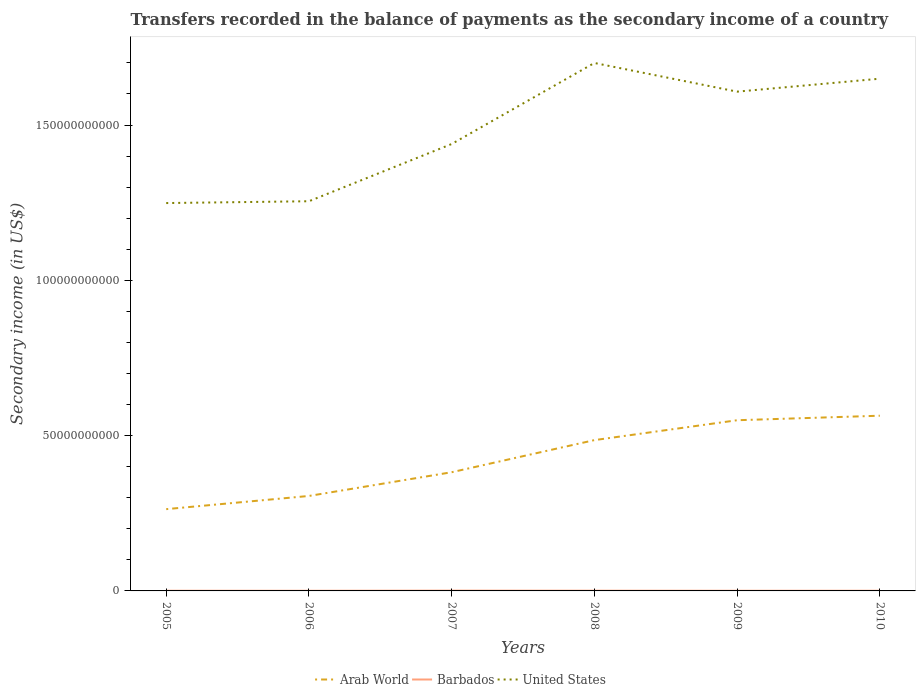How many different coloured lines are there?
Offer a terse response. 3. Does the line corresponding to Arab World intersect with the line corresponding to United States?
Offer a very short reply. No. Across all years, what is the maximum secondary income of in Arab World?
Provide a succinct answer. 2.63e+1. In which year was the secondary income of in United States maximum?
Offer a terse response. 2005. What is the total secondary income of in United States in the graph?
Keep it short and to the point. -1.90e+1. What is the difference between the highest and the second highest secondary income of in United States?
Your answer should be very brief. 4.51e+1. What is the difference between the highest and the lowest secondary income of in Arab World?
Your answer should be very brief. 3. Is the secondary income of in Arab World strictly greater than the secondary income of in Barbados over the years?
Offer a very short reply. No. How many lines are there?
Provide a succinct answer. 3. How many years are there in the graph?
Give a very brief answer. 6. Are the values on the major ticks of Y-axis written in scientific E-notation?
Your answer should be very brief. No. Does the graph contain any zero values?
Your answer should be compact. No. Does the graph contain grids?
Offer a terse response. No. Where does the legend appear in the graph?
Offer a very short reply. Bottom center. How many legend labels are there?
Keep it short and to the point. 3. What is the title of the graph?
Your response must be concise. Transfers recorded in the balance of payments as the secondary income of a country. Does "Ukraine" appear as one of the legend labels in the graph?
Your response must be concise. No. What is the label or title of the Y-axis?
Your answer should be very brief. Secondary income (in US$). What is the Secondary income (in US$) in Arab World in 2005?
Offer a very short reply. 2.63e+1. What is the Secondary income (in US$) in Barbados in 2005?
Make the answer very short. 5.83e+07. What is the Secondary income (in US$) of United States in 2005?
Your response must be concise. 1.25e+11. What is the Secondary income (in US$) in Arab World in 2006?
Provide a short and direct response. 3.06e+1. What is the Secondary income (in US$) in Barbados in 2006?
Provide a succinct answer. 4.97e+07. What is the Secondary income (in US$) in United States in 2006?
Provide a short and direct response. 1.25e+11. What is the Secondary income (in US$) of Arab World in 2007?
Make the answer very short. 3.82e+1. What is the Secondary income (in US$) of Barbados in 2007?
Offer a terse response. 9.69e+07. What is the Secondary income (in US$) in United States in 2007?
Your answer should be very brief. 1.44e+11. What is the Secondary income (in US$) of Arab World in 2008?
Provide a short and direct response. 4.86e+1. What is the Secondary income (in US$) of Barbados in 2008?
Make the answer very short. 7.56e+07. What is the Secondary income (in US$) of United States in 2008?
Your answer should be very brief. 1.70e+11. What is the Secondary income (in US$) in Arab World in 2009?
Your response must be concise. 5.50e+1. What is the Secondary income (in US$) in Barbados in 2009?
Offer a very short reply. 5.61e+07. What is the Secondary income (in US$) in United States in 2009?
Your response must be concise. 1.61e+11. What is the Secondary income (in US$) of Arab World in 2010?
Your answer should be compact. 5.64e+1. What is the Secondary income (in US$) in Barbados in 2010?
Offer a very short reply. 6.13e+07. What is the Secondary income (in US$) in United States in 2010?
Your response must be concise. 1.65e+11. Across all years, what is the maximum Secondary income (in US$) of Arab World?
Keep it short and to the point. 5.64e+1. Across all years, what is the maximum Secondary income (in US$) of Barbados?
Ensure brevity in your answer.  9.69e+07. Across all years, what is the maximum Secondary income (in US$) of United States?
Your answer should be compact. 1.70e+11. Across all years, what is the minimum Secondary income (in US$) in Arab World?
Give a very brief answer. 2.63e+1. Across all years, what is the minimum Secondary income (in US$) in Barbados?
Your answer should be compact. 4.97e+07. Across all years, what is the minimum Secondary income (in US$) of United States?
Ensure brevity in your answer.  1.25e+11. What is the total Secondary income (in US$) of Arab World in the graph?
Give a very brief answer. 2.55e+11. What is the total Secondary income (in US$) of Barbados in the graph?
Ensure brevity in your answer.  3.98e+08. What is the total Secondary income (in US$) of United States in the graph?
Keep it short and to the point. 8.90e+11. What is the difference between the Secondary income (in US$) in Arab World in 2005 and that in 2006?
Your answer should be very brief. -4.25e+09. What is the difference between the Secondary income (in US$) of Barbados in 2005 and that in 2006?
Provide a short and direct response. 8.51e+06. What is the difference between the Secondary income (in US$) of United States in 2005 and that in 2006?
Your response must be concise. -5.83e+08. What is the difference between the Secondary income (in US$) of Arab World in 2005 and that in 2007?
Provide a short and direct response. -1.19e+1. What is the difference between the Secondary income (in US$) of Barbados in 2005 and that in 2007?
Offer a terse response. -3.86e+07. What is the difference between the Secondary income (in US$) in United States in 2005 and that in 2007?
Your response must be concise. -1.90e+1. What is the difference between the Secondary income (in US$) of Arab World in 2005 and that in 2008?
Provide a succinct answer. -2.22e+1. What is the difference between the Secondary income (in US$) in Barbados in 2005 and that in 2008?
Your answer should be compact. -1.73e+07. What is the difference between the Secondary income (in US$) in United States in 2005 and that in 2008?
Ensure brevity in your answer.  -4.51e+1. What is the difference between the Secondary income (in US$) in Arab World in 2005 and that in 2009?
Ensure brevity in your answer.  -2.86e+1. What is the difference between the Secondary income (in US$) of Barbados in 2005 and that in 2009?
Your answer should be very brief. 2.20e+06. What is the difference between the Secondary income (in US$) in United States in 2005 and that in 2009?
Your answer should be very brief. -3.59e+1. What is the difference between the Secondary income (in US$) in Arab World in 2005 and that in 2010?
Give a very brief answer. -3.01e+1. What is the difference between the Secondary income (in US$) of Barbados in 2005 and that in 2010?
Provide a succinct answer. -3.06e+06. What is the difference between the Secondary income (in US$) in United States in 2005 and that in 2010?
Offer a terse response. -4.00e+1. What is the difference between the Secondary income (in US$) in Arab World in 2006 and that in 2007?
Offer a very short reply. -7.64e+09. What is the difference between the Secondary income (in US$) of Barbados in 2006 and that in 2007?
Keep it short and to the point. -4.71e+07. What is the difference between the Secondary income (in US$) of United States in 2006 and that in 2007?
Give a very brief answer. -1.84e+1. What is the difference between the Secondary income (in US$) in Arab World in 2006 and that in 2008?
Your response must be concise. -1.80e+1. What is the difference between the Secondary income (in US$) in Barbados in 2006 and that in 2008?
Ensure brevity in your answer.  -2.58e+07. What is the difference between the Secondary income (in US$) in United States in 2006 and that in 2008?
Ensure brevity in your answer.  -4.45e+1. What is the difference between the Secondary income (in US$) of Arab World in 2006 and that in 2009?
Make the answer very short. -2.44e+1. What is the difference between the Secondary income (in US$) in Barbados in 2006 and that in 2009?
Give a very brief answer. -6.32e+06. What is the difference between the Secondary income (in US$) in United States in 2006 and that in 2009?
Give a very brief answer. -3.53e+1. What is the difference between the Secondary income (in US$) of Arab World in 2006 and that in 2010?
Offer a very short reply. -2.58e+1. What is the difference between the Secondary income (in US$) of Barbados in 2006 and that in 2010?
Your answer should be very brief. -1.16e+07. What is the difference between the Secondary income (in US$) of United States in 2006 and that in 2010?
Ensure brevity in your answer.  -3.95e+1. What is the difference between the Secondary income (in US$) in Arab World in 2007 and that in 2008?
Your answer should be compact. -1.03e+1. What is the difference between the Secondary income (in US$) of Barbados in 2007 and that in 2008?
Provide a short and direct response. 2.13e+07. What is the difference between the Secondary income (in US$) in United States in 2007 and that in 2008?
Provide a succinct answer. -2.61e+1. What is the difference between the Secondary income (in US$) of Arab World in 2007 and that in 2009?
Your response must be concise. -1.67e+1. What is the difference between the Secondary income (in US$) in Barbados in 2007 and that in 2009?
Offer a terse response. 4.08e+07. What is the difference between the Secondary income (in US$) in United States in 2007 and that in 2009?
Ensure brevity in your answer.  -1.69e+1. What is the difference between the Secondary income (in US$) of Arab World in 2007 and that in 2010?
Make the answer very short. -1.82e+1. What is the difference between the Secondary income (in US$) in Barbados in 2007 and that in 2010?
Your response must be concise. 3.56e+07. What is the difference between the Secondary income (in US$) in United States in 2007 and that in 2010?
Keep it short and to the point. -2.10e+1. What is the difference between the Secondary income (in US$) of Arab World in 2008 and that in 2009?
Give a very brief answer. -6.40e+09. What is the difference between the Secondary income (in US$) in Barbados in 2008 and that in 2009?
Your answer should be compact. 1.95e+07. What is the difference between the Secondary income (in US$) in United States in 2008 and that in 2009?
Provide a succinct answer. 9.24e+09. What is the difference between the Secondary income (in US$) in Arab World in 2008 and that in 2010?
Make the answer very short. -7.86e+09. What is the difference between the Secondary income (in US$) in Barbados in 2008 and that in 2010?
Give a very brief answer. 1.43e+07. What is the difference between the Secondary income (in US$) in United States in 2008 and that in 2010?
Your answer should be compact. 5.06e+09. What is the difference between the Secondary income (in US$) in Arab World in 2009 and that in 2010?
Make the answer very short. -1.45e+09. What is the difference between the Secondary income (in US$) of Barbados in 2009 and that in 2010?
Ensure brevity in your answer.  -5.26e+06. What is the difference between the Secondary income (in US$) in United States in 2009 and that in 2010?
Ensure brevity in your answer.  -4.17e+09. What is the difference between the Secondary income (in US$) of Arab World in 2005 and the Secondary income (in US$) of Barbados in 2006?
Make the answer very short. 2.63e+1. What is the difference between the Secondary income (in US$) in Arab World in 2005 and the Secondary income (in US$) in United States in 2006?
Make the answer very short. -9.91e+1. What is the difference between the Secondary income (in US$) of Barbados in 2005 and the Secondary income (in US$) of United States in 2006?
Provide a succinct answer. -1.25e+11. What is the difference between the Secondary income (in US$) in Arab World in 2005 and the Secondary income (in US$) in Barbados in 2007?
Make the answer very short. 2.62e+1. What is the difference between the Secondary income (in US$) in Arab World in 2005 and the Secondary income (in US$) in United States in 2007?
Give a very brief answer. -1.18e+11. What is the difference between the Secondary income (in US$) of Barbados in 2005 and the Secondary income (in US$) of United States in 2007?
Ensure brevity in your answer.  -1.44e+11. What is the difference between the Secondary income (in US$) in Arab World in 2005 and the Secondary income (in US$) in Barbados in 2008?
Provide a short and direct response. 2.63e+1. What is the difference between the Secondary income (in US$) in Arab World in 2005 and the Secondary income (in US$) in United States in 2008?
Give a very brief answer. -1.44e+11. What is the difference between the Secondary income (in US$) in Barbados in 2005 and the Secondary income (in US$) in United States in 2008?
Your answer should be compact. -1.70e+11. What is the difference between the Secondary income (in US$) in Arab World in 2005 and the Secondary income (in US$) in Barbados in 2009?
Make the answer very short. 2.63e+1. What is the difference between the Secondary income (in US$) in Arab World in 2005 and the Secondary income (in US$) in United States in 2009?
Provide a short and direct response. -1.34e+11. What is the difference between the Secondary income (in US$) in Barbados in 2005 and the Secondary income (in US$) in United States in 2009?
Your response must be concise. -1.61e+11. What is the difference between the Secondary income (in US$) in Arab World in 2005 and the Secondary income (in US$) in Barbados in 2010?
Keep it short and to the point. 2.63e+1. What is the difference between the Secondary income (in US$) in Arab World in 2005 and the Secondary income (in US$) in United States in 2010?
Offer a very short reply. -1.39e+11. What is the difference between the Secondary income (in US$) in Barbados in 2005 and the Secondary income (in US$) in United States in 2010?
Your answer should be very brief. -1.65e+11. What is the difference between the Secondary income (in US$) of Arab World in 2006 and the Secondary income (in US$) of Barbados in 2007?
Keep it short and to the point. 3.05e+1. What is the difference between the Secondary income (in US$) of Arab World in 2006 and the Secondary income (in US$) of United States in 2007?
Provide a short and direct response. -1.13e+11. What is the difference between the Secondary income (in US$) of Barbados in 2006 and the Secondary income (in US$) of United States in 2007?
Your answer should be compact. -1.44e+11. What is the difference between the Secondary income (in US$) in Arab World in 2006 and the Secondary income (in US$) in Barbados in 2008?
Your answer should be compact. 3.05e+1. What is the difference between the Secondary income (in US$) in Arab World in 2006 and the Secondary income (in US$) in United States in 2008?
Provide a succinct answer. -1.39e+11. What is the difference between the Secondary income (in US$) of Barbados in 2006 and the Secondary income (in US$) of United States in 2008?
Your response must be concise. -1.70e+11. What is the difference between the Secondary income (in US$) of Arab World in 2006 and the Secondary income (in US$) of Barbados in 2009?
Give a very brief answer. 3.05e+1. What is the difference between the Secondary income (in US$) in Arab World in 2006 and the Secondary income (in US$) in United States in 2009?
Give a very brief answer. -1.30e+11. What is the difference between the Secondary income (in US$) in Barbados in 2006 and the Secondary income (in US$) in United States in 2009?
Your answer should be very brief. -1.61e+11. What is the difference between the Secondary income (in US$) of Arab World in 2006 and the Secondary income (in US$) of Barbados in 2010?
Offer a very short reply. 3.05e+1. What is the difference between the Secondary income (in US$) of Arab World in 2006 and the Secondary income (in US$) of United States in 2010?
Your answer should be very brief. -1.34e+11. What is the difference between the Secondary income (in US$) in Barbados in 2006 and the Secondary income (in US$) in United States in 2010?
Give a very brief answer. -1.65e+11. What is the difference between the Secondary income (in US$) of Arab World in 2007 and the Secondary income (in US$) of Barbados in 2008?
Offer a very short reply. 3.81e+1. What is the difference between the Secondary income (in US$) in Arab World in 2007 and the Secondary income (in US$) in United States in 2008?
Offer a terse response. -1.32e+11. What is the difference between the Secondary income (in US$) of Barbados in 2007 and the Secondary income (in US$) of United States in 2008?
Offer a terse response. -1.70e+11. What is the difference between the Secondary income (in US$) in Arab World in 2007 and the Secondary income (in US$) in Barbados in 2009?
Provide a short and direct response. 3.82e+1. What is the difference between the Secondary income (in US$) of Arab World in 2007 and the Secondary income (in US$) of United States in 2009?
Offer a terse response. -1.23e+11. What is the difference between the Secondary income (in US$) of Barbados in 2007 and the Secondary income (in US$) of United States in 2009?
Make the answer very short. -1.61e+11. What is the difference between the Secondary income (in US$) of Arab World in 2007 and the Secondary income (in US$) of Barbados in 2010?
Provide a succinct answer. 3.82e+1. What is the difference between the Secondary income (in US$) of Arab World in 2007 and the Secondary income (in US$) of United States in 2010?
Ensure brevity in your answer.  -1.27e+11. What is the difference between the Secondary income (in US$) in Barbados in 2007 and the Secondary income (in US$) in United States in 2010?
Provide a succinct answer. -1.65e+11. What is the difference between the Secondary income (in US$) of Arab World in 2008 and the Secondary income (in US$) of Barbados in 2009?
Your answer should be compact. 4.85e+1. What is the difference between the Secondary income (in US$) of Arab World in 2008 and the Secondary income (in US$) of United States in 2009?
Your answer should be compact. -1.12e+11. What is the difference between the Secondary income (in US$) of Barbados in 2008 and the Secondary income (in US$) of United States in 2009?
Keep it short and to the point. -1.61e+11. What is the difference between the Secondary income (in US$) in Arab World in 2008 and the Secondary income (in US$) in Barbados in 2010?
Offer a terse response. 4.85e+1. What is the difference between the Secondary income (in US$) in Arab World in 2008 and the Secondary income (in US$) in United States in 2010?
Offer a terse response. -1.16e+11. What is the difference between the Secondary income (in US$) in Barbados in 2008 and the Secondary income (in US$) in United States in 2010?
Give a very brief answer. -1.65e+11. What is the difference between the Secondary income (in US$) in Arab World in 2009 and the Secondary income (in US$) in Barbados in 2010?
Your answer should be very brief. 5.49e+1. What is the difference between the Secondary income (in US$) in Arab World in 2009 and the Secondary income (in US$) in United States in 2010?
Offer a terse response. -1.10e+11. What is the difference between the Secondary income (in US$) in Barbados in 2009 and the Secondary income (in US$) in United States in 2010?
Give a very brief answer. -1.65e+11. What is the average Secondary income (in US$) in Arab World per year?
Your response must be concise. 4.25e+1. What is the average Secondary income (in US$) of Barbados per year?
Make the answer very short. 6.63e+07. What is the average Secondary income (in US$) of United States per year?
Make the answer very short. 1.48e+11. In the year 2005, what is the difference between the Secondary income (in US$) of Arab World and Secondary income (in US$) of Barbados?
Ensure brevity in your answer.  2.63e+1. In the year 2005, what is the difference between the Secondary income (in US$) in Arab World and Secondary income (in US$) in United States?
Keep it short and to the point. -9.86e+1. In the year 2005, what is the difference between the Secondary income (in US$) in Barbados and Secondary income (in US$) in United States?
Make the answer very short. -1.25e+11. In the year 2006, what is the difference between the Secondary income (in US$) in Arab World and Secondary income (in US$) in Barbados?
Provide a succinct answer. 3.05e+1. In the year 2006, what is the difference between the Secondary income (in US$) in Arab World and Secondary income (in US$) in United States?
Ensure brevity in your answer.  -9.49e+1. In the year 2006, what is the difference between the Secondary income (in US$) of Barbados and Secondary income (in US$) of United States?
Make the answer very short. -1.25e+11. In the year 2007, what is the difference between the Secondary income (in US$) of Arab World and Secondary income (in US$) of Barbados?
Make the answer very short. 3.81e+1. In the year 2007, what is the difference between the Secondary income (in US$) in Arab World and Secondary income (in US$) in United States?
Offer a very short reply. -1.06e+11. In the year 2007, what is the difference between the Secondary income (in US$) of Barbados and Secondary income (in US$) of United States?
Offer a very short reply. -1.44e+11. In the year 2008, what is the difference between the Secondary income (in US$) of Arab World and Secondary income (in US$) of Barbados?
Your response must be concise. 4.85e+1. In the year 2008, what is the difference between the Secondary income (in US$) in Arab World and Secondary income (in US$) in United States?
Offer a very short reply. -1.21e+11. In the year 2008, what is the difference between the Secondary income (in US$) in Barbados and Secondary income (in US$) in United States?
Your answer should be very brief. -1.70e+11. In the year 2009, what is the difference between the Secondary income (in US$) in Arab World and Secondary income (in US$) in Barbados?
Keep it short and to the point. 5.49e+1. In the year 2009, what is the difference between the Secondary income (in US$) of Arab World and Secondary income (in US$) of United States?
Make the answer very short. -1.06e+11. In the year 2009, what is the difference between the Secondary income (in US$) of Barbados and Secondary income (in US$) of United States?
Provide a short and direct response. -1.61e+11. In the year 2010, what is the difference between the Secondary income (in US$) of Arab World and Secondary income (in US$) of Barbados?
Your response must be concise. 5.64e+1. In the year 2010, what is the difference between the Secondary income (in US$) in Arab World and Secondary income (in US$) in United States?
Keep it short and to the point. -1.09e+11. In the year 2010, what is the difference between the Secondary income (in US$) in Barbados and Secondary income (in US$) in United States?
Offer a terse response. -1.65e+11. What is the ratio of the Secondary income (in US$) of Arab World in 2005 to that in 2006?
Your response must be concise. 0.86. What is the ratio of the Secondary income (in US$) in Barbados in 2005 to that in 2006?
Offer a terse response. 1.17. What is the ratio of the Secondary income (in US$) in Arab World in 2005 to that in 2007?
Provide a short and direct response. 0.69. What is the ratio of the Secondary income (in US$) in Barbados in 2005 to that in 2007?
Your answer should be very brief. 0.6. What is the ratio of the Secondary income (in US$) in United States in 2005 to that in 2007?
Your answer should be very brief. 0.87. What is the ratio of the Secondary income (in US$) in Arab World in 2005 to that in 2008?
Give a very brief answer. 0.54. What is the ratio of the Secondary income (in US$) in Barbados in 2005 to that in 2008?
Make the answer very short. 0.77. What is the ratio of the Secondary income (in US$) of United States in 2005 to that in 2008?
Keep it short and to the point. 0.73. What is the ratio of the Secondary income (in US$) of Arab World in 2005 to that in 2009?
Make the answer very short. 0.48. What is the ratio of the Secondary income (in US$) in Barbados in 2005 to that in 2009?
Ensure brevity in your answer.  1.04. What is the ratio of the Secondary income (in US$) of United States in 2005 to that in 2009?
Make the answer very short. 0.78. What is the ratio of the Secondary income (in US$) in Arab World in 2005 to that in 2010?
Your response must be concise. 0.47. What is the ratio of the Secondary income (in US$) in Barbados in 2005 to that in 2010?
Your answer should be very brief. 0.95. What is the ratio of the Secondary income (in US$) of United States in 2005 to that in 2010?
Your response must be concise. 0.76. What is the ratio of the Secondary income (in US$) in Arab World in 2006 to that in 2007?
Provide a succinct answer. 0.8. What is the ratio of the Secondary income (in US$) in Barbados in 2006 to that in 2007?
Your answer should be compact. 0.51. What is the ratio of the Secondary income (in US$) in United States in 2006 to that in 2007?
Provide a succinct answer. 0.87. What is the ratio of the Secondary income (in US$) in Arab World in 2006 to that in 2008?
Offer a very short reply. 0.63. What is the ratio of the Secondary income (in US$) in Barbados in 2006 to that in 2008?
Provide a succinct answer. 0.66. What is the ratio of the Secondary income (in US$) in United States in 2006 to that in 2008?
Offer a terse response. 0.74. What is the ratio of the Secondary income (in US$) in Arab World in 2006 to that in 2009?
Your answer should be very brief. 0.56. What is the ratio of the Secondary income (in US$) in Barbados in 2006 to that in 2009?
Offer a very short reply. 0.89. What is the ratio of the Secondary income (in US$) of United States in 2006 to that in 2009?
Offer a very short reply. 0.78. What is the ratio of the Secondary income (in US$) of Arab World in 2006 to that in 2010?
Make the answer very short. 0.54. What is the ratio of the Secondary income (in US$) in Barbados in 2006 to that in 2010?
Your response must be concise. 0.81. What is the ratio of the Secondary income (in US$) of United States in 2006 to that in 2010?
Give a very brief answer. 0.76. What is the ratio of the Secondary income (in US$) in Arab World in 2007 to that in 2008?
Ensure brevity in your answer.  0.79. What is the ratio of the Secondary income (in US$) of Barbados in 2007 to that in 2008?
Your response must be concise. 1.28. What is the ratio of the Secondary income (in US$) of United States in 2007 to that in 2008?
Keep it short and to the point. 0.85. What is the ratio of the Secondary income (in US$) in Arab World in 2007 to that in 2009?
Provide a short and direct response. 0.7. What is the ratio of the Secondary income (in US$) in Barbados in 2007 to that in 2009?
Give a very brief answer. 1.73. What is the ratio of the Secondary income (in US$) in United States in 2007 to that in 2009?
Make the answer very short. 0.9. What is the ratio of the Secondary income (in US$) of Arab World in 2007 to that in 2010?
Your answer should be very brief. 0.68. What is the ratio of the Secondary income (in US$) of Barbados in 2007 to that in 2010?
Offer a very short reply. 1.58. What is the ratio of the Secondary income (in US$) of United States in 2007 to that in 2010?
Your answer should be very brief. 0.87. What is the ratio of the Secondary income (in US$) in Arab World in 2008 to that in 2009?
Provide a short and direct response. 0.88. What is the ratio of the Secondary income (in US$) of Barbados in 2008 to that in 2009?
Make the answer very short. 1.35. What is the ratio of the Secondary income (in US$) in United States in 2008 to that in 2009?
Ensure brevity in your answer.  1.06. What is the ratio of the Secondary income (in US$) of Arab World in 2008 to that in 2010?
Your answer should be very brief. 0.86. What is the ratio of the Secondary income (in US$) in Barbados in 2008 to that in 2010?
Your answer should be compact. 1.23. What is the ratio of the Secondary income (in US$) in United States in 2008 to that in 2010?
Your response must be concise. 1.03. What is the ratio of the Secondary income (in US$) of Arab World in 2009 to that in 2010?
Your answer should be compact. 0.97. What is the ratio of the Secondary income (in US$) in Barbados in 2009 to that in 2010?
Give a very brief answer. 0.91. What is the ratio of the Secondary income (in US$) of United States in 2009 to that in 2010?
Give a very brief answer. 0.97. What is the difference between the highest and the second highest Secondary income (in US$) in Arab World?
Your answer should be very brief. 1.45e+09. What is the difference between the highest and the second highest Secondary income (in US$) in Barbados?
Offer a very short reply. 2.13e+07. What is the difference between the highest and the second highest Secondary income (in US$) of United States?
Offer a very short reply. 5.06e+09. What is the difference between the highest and the lowest Secondary income (in US$) of Arab World?
Provide a succinct answer. 3.01e+1. What is the difference between the highest and the lowest Secondary income (in US$) in Barbados?
Keep it short and to the point. 4.71e+07. What is the difference between the highest and the lowest Secondary income (in US$) in United States?
Ensure brevity in your answer.  4.51e+1. 